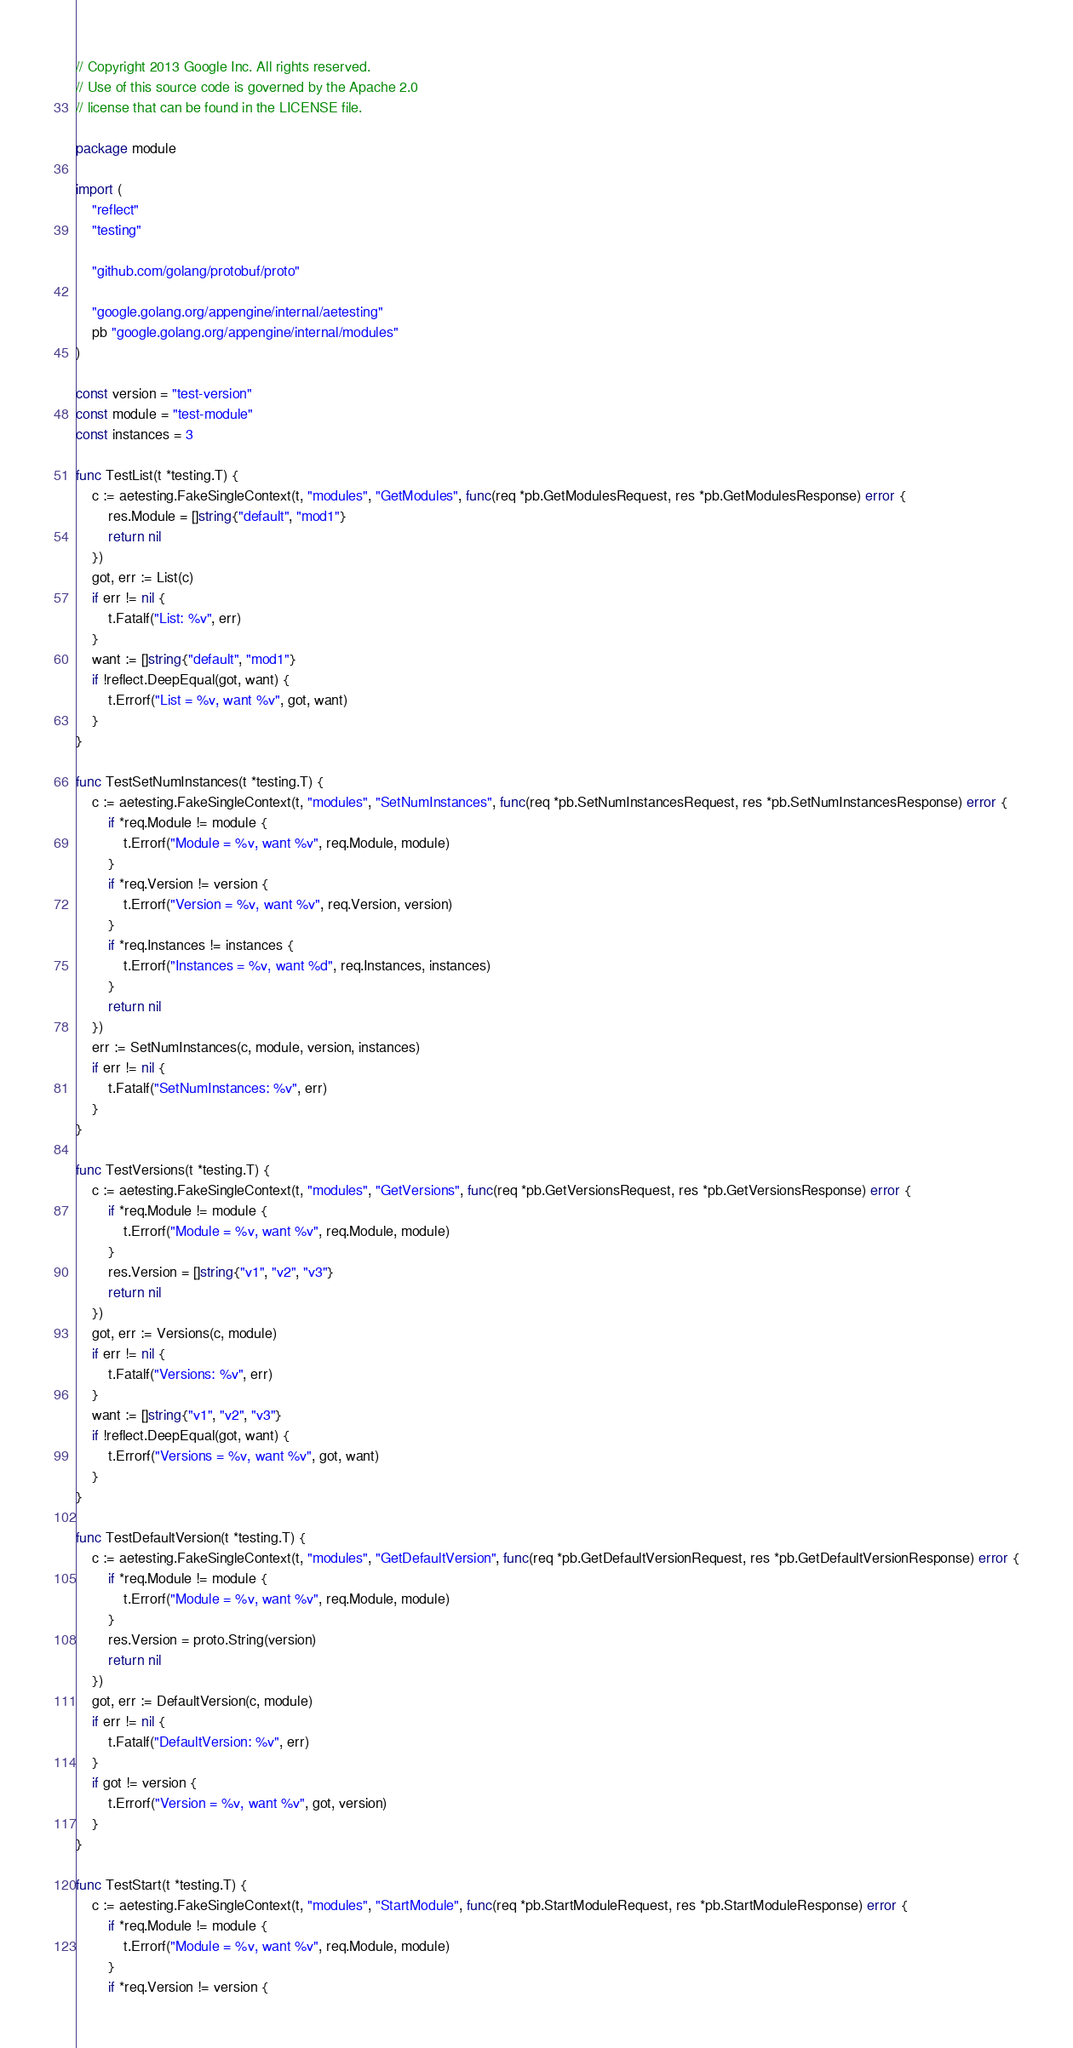Convert code to text. <code><loc_0><loc_0><loc_500><loc_500><_Go_>// Copyright 2013 Google Inc. All rights reserved.
// Use of this source code is governed by the Apache 2.0
// license that can be found in the LICENSE file.

package module

import (
	"reflect"
	"testing"

	"github.com/golang/protobuf/proto"

	"google.golang.org/appengine/internal/aetesting"
	pb "google.golang.org/appengine/internal/modules"
)

const version = "test-version"
const module = "test-module"
const instances = 3

func TestList(t *testing.T) {
	c := aetesting.FakeSingleContext(t, "modules", "GetModules", func(req *pb.GetModulesRequest, res *pb.GetModulesResponse) error {
		res.Module = []string{"default", "mod1"}
		return nil
	})
	got, err := List(c)
	if err != nil {
		t.Fatalf("List: %v", err)
	}
	want := []string{"default", "mod1"}
	if !reflect.DeepEqual(got, want) {
		t.Errorf("List = %v, want %v", got, want)
	}
}

func TestSetNumInstances(t *testing.T) {
	c := aetesting.FakeSingleContext(t, "modules", "SetNumInstances", func(req *pb.SetNumInstancesRequest, res *pb.SetNumInstancesResponse) error {
		if *req.Module != module {
			t.Errorf("Module = %v, want %v", req.Module, module)
		}
		if *req.Version != version {
			t.Errorf("Version = %v, want %v", req.Version, version)
		}
		if *req.Instances != instances {
			t.Errorf("Instances = %v, want %d", req.Instances, instances)
		}
		return nil
	})
	err := SetNumInstances(c, module, version, instances)
	if err != nil {
		t.Fatalf("SetNumInstances: %v", err)
	}
}

func TestVersions(t *testing.T) {
	c := aetesting.FakeSingleContext(t, "modules", "GetVersions", func(req *pb.GetVersionsRequest, res *pb.GetVersionsResponse) error {
		if *req.Module != module {
			t.Errorf("Module = %v, want %v", req.Module, module)
		}
		res.Version = []string{"v1", "v2", "v3"}
		return nil
	})
	got, err := Versions(c, module)
	if err != nil {
		t.Fatalf("Versions: %v", err)
	}
	want := []string{"v1", "v2", "v3"}
	if !reflect.DeepEqual(got, want) {
		t.Errorf("Versions = %v, want %v", got, want)
	}
}

func TestDefaultVersion(t *testing.T) {
	c := aetesting.FakeSingleContext(t, "modules", "GetDefaultVersion", func(req *pb.GetDefaultVersionRequest, res *pb.GetDefaultVersionResponse) error {
		if *req.Module != module {
			t.Errorf("Module = %v, want %v", req.Module, module)
		}
		res.Version = proto.String(version)
		return nil
	})
	got, err := DefaultVersion(c, module)
	if err != nil {
		t.Fatalf("DefaultVersion: %v", err)
	}
	if got != version {
		t.Errorf("Version = %v, want %v", got, version)
	}
}

func TestStart(t *testing.T) {
	c := aetesting.FakeSingleContext(t, "modules", "StartModule", func(req *pb.StartModuleRequest, res *pb.StartModuleResponse) error {
		if *req.Module != module {
			t.Errorf("Module = %v, want %v", req.Module, module)
		}
		if *req.Version != version {</code> 